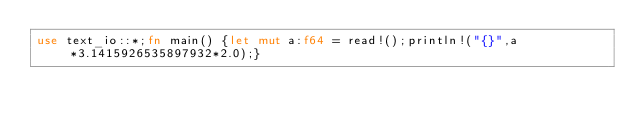Convert code to text. <code><loc_0><loc_0><loc_500><loc_500><_Rust_>use text_io::*;fn main() {let mut a:f64 = read!();println!("{}",a*3.1415926535897932*2.0);}</code> 